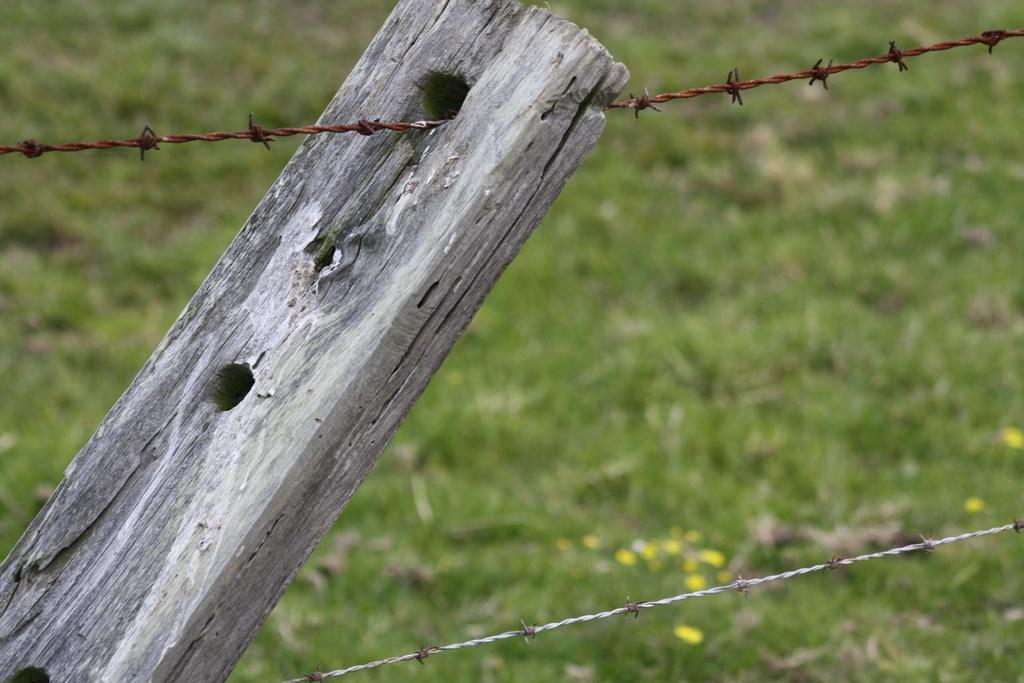What type of material is the stick in the image made of? The wooden stick in the image is made of wood. What type of barrier can be seen in the image? There is a metal fence in the image. What type of vegetation is present on the surface in the image? Grass is present on the surface in the image. How does the wooden stick contribute to the growth of the grass in the image? The wooden stick does not contribute to the growth of the grass in the image; it is a separate object. What part of the metal fence is visible in the image? The metal fence is a continuous structure, and it is not possible to identify a specific part of it as being visible in the image. 